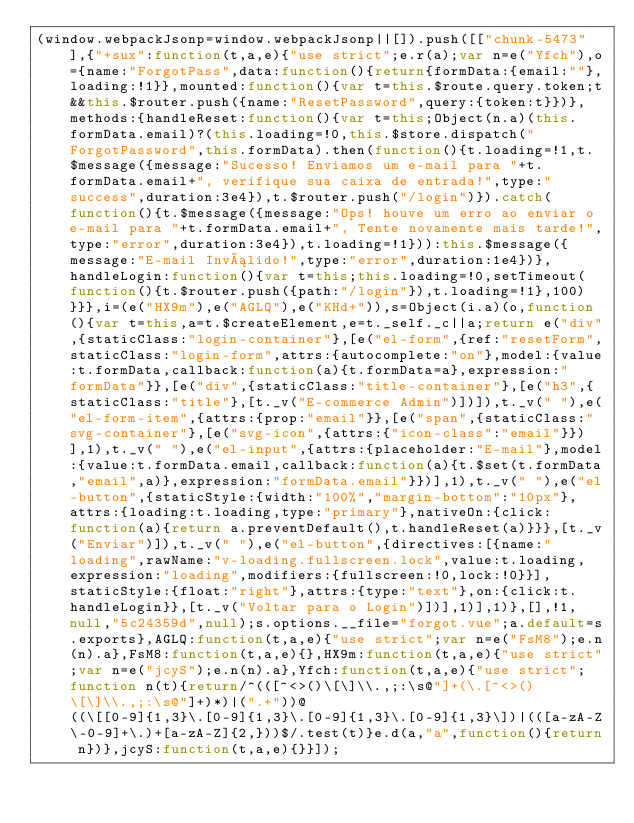Convert code to text. <code><loc_0><loc_0><loc_500><loc_500><_JavaScript_>(window.webpackJsonp=window.webpackJsonp||[]).push([["chunk-5473"],{"+sux":function(t,a,e){"use strict";e.r(a);var n=e("Yfch"),o={name:"ForgotPass",data:function(){return{formData:{email:""},loading:!1}},mounted:function(){var t=this.$route.query.token;t&&this.$router.push({name:"ResetPassword",query:{token:t}})},methods:{handleReset:function(){var t=this;Object(n.a)(this.formData.email)?(this.loading=!0,this.$store.dispatch("ForgotPassword",this.formData).then(function(){t.loading=!1,t.$message({message:"Sucesso! Enviamos um e-mail para "+t.formData.email+", verifique sua caixa de entrada!",type:"success",duration:3e4}),t.$router.push("/login")}).catch(function(){t.$message({message:"Ops! houve um erro ao enviar o e-mail para "+t.formData.email+", Tente novamente mais tarde!",type:"error",duration:3e4}),t.loading=!1})):this.$message({message:"E-mail Inválido!",type:"error",duration:1e4})},handleLogin:function(){var t=this;this.loading=!0,setTimeout(function(){t.$router.push({path:"/login"}),t.loading=!1},100)}}},i=(e("HX9m"),e("AGLQ"),e("KHd+")),s=Object(i.a)(o,function(){var t=this,a=t.$createElement,e=t._self._c||a;return e("div",{staticClass:"login-container"},[e("el-form",{ref:"resetForm",staticClass:"login-form",attrs:{autocomplete:"on"},model:{value:t.formData,callback:function(a){t.formData=a},expression:"formData"}},[e("div",{staticClass:"title-container"},[e("h3",{staticClass:"title"},[t._v("E-commerce Admin")])]),t._v(" "),e("el-form-item",{attrs:{prop:"email"}},[e("span",{staticClass:"svg-container"},[e("svg-icon",{attrs:{"icon-class":"email"}})],1),t._v(" "),e("el-input",{attrs:{placeholder:"E-mail"},model:{value:t.formData.email,callback:function(a){t.$set(t.formData,"email",a)},expression:"formData.email"}})],1),t._v(" "),e("el-button",{staticStyle:{width:"100%","margin-bottom":"10px"},attrs:{loading:t.loading,type:"primary"},nativeOn:{click:function(a){return a.preventDefault(),t.handleReset(a)}}},[t._v("Enviar")]),t._v(" "),e("el-button",{directives:[{name:"loading",rawName:"v-loading.fullscreen.lock",value:t.loading,expression:"loading",modifiers:{fullscreen:!0,lock:!0}}],staticStyle:{float:"right"},attrs:{type:"text"},on:{click:t.handleLogin}},[t._v("Voltar para o Login")])],1)],1)},[],!1,null,"5c24359d",null);s.options.__file="forgot.vue";a.default=s.exports},AGLQ:function(t,a,e){"use strict";var n=e("FsM8");e.n(n).a},FsM8:function(t,a,e){},HX9m:function(t,a,e){"use strict";var n=e("jcyS");e.n(n).a},Yfch:function(t,a,e){"use strict";function n(t){return/^(([^<>()\[\]\\.,;:\s@"]+(\.[^<>()\[\]\\.,;:\s@"]+)*)|(".+"))@((\[[0-9]{1,3}\.[0-9]{1,3}\.[0-9]{1,3}\.[0-9]{1,3}\])|(([a-zA-Z\-0-9]+\.)+[a-zA-Z]{2,}))$/.test(t)}e.d(a,"a",function(){return n})},jcyS:function(t,a,e){}}]);</code> 